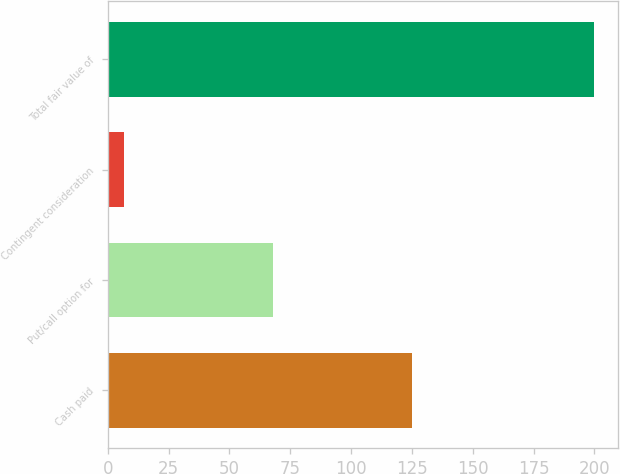Convert chart to OTSL. <chart><loc_0><loc_0><loc_500><loc_500><bar_chart><fcel>Cash paid<fcel>Put/call option for<fcel>Contingent consideration<fcel>Total fair value of<nl><fcel>125<fcel>68<fcel>6.8<fcel>199.8<nl></chart> 